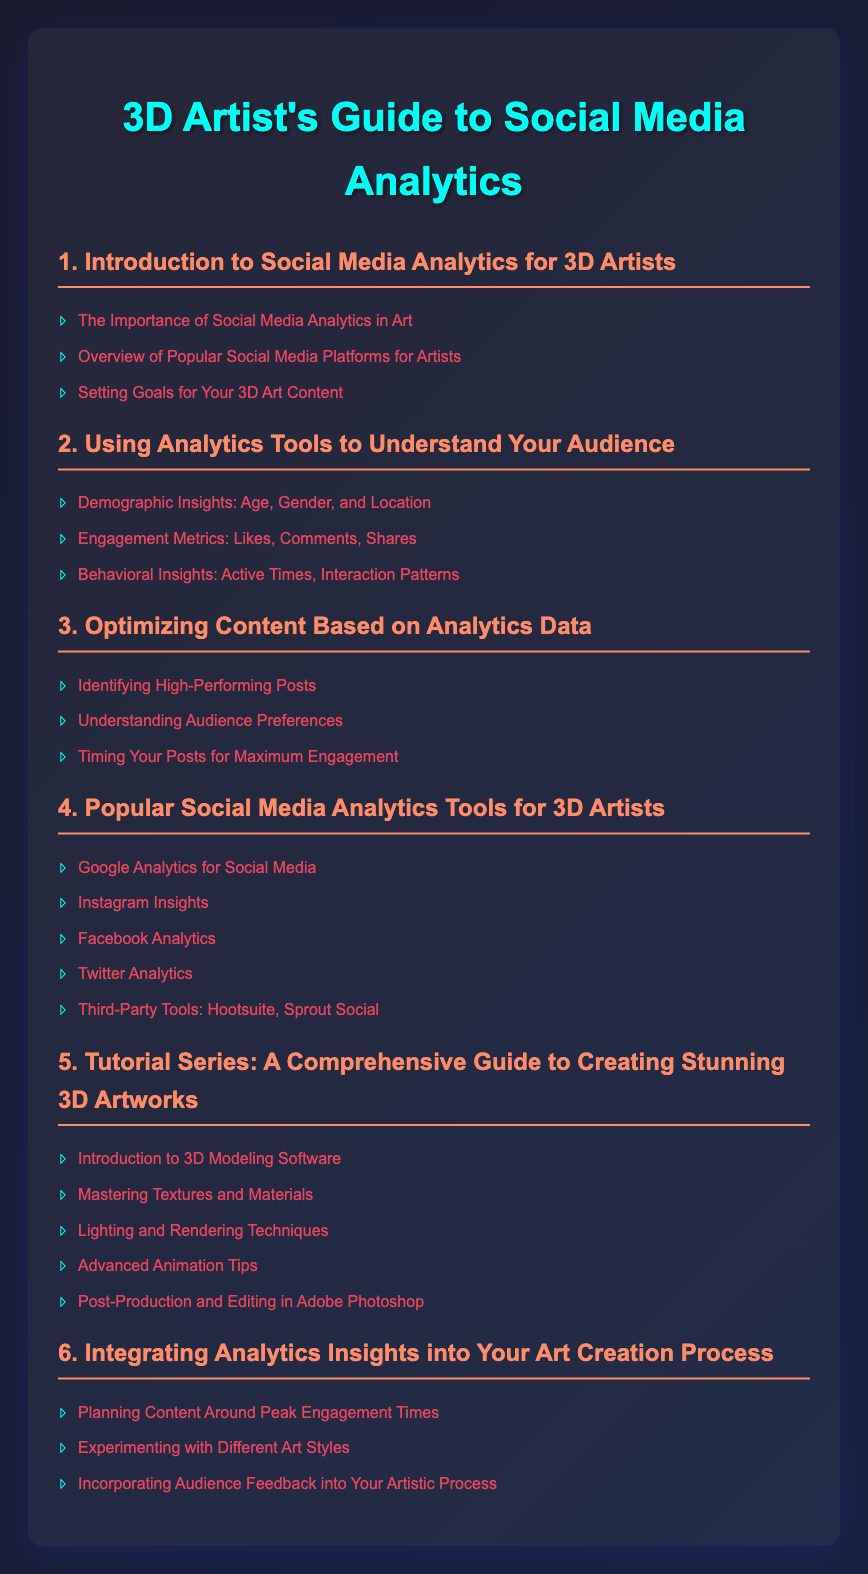What is the title of the document? The title is mentioned in the <title> tag of the document.
Answer: 3D Artist's Guide to Social Media Analytics How many sections are there in the Table of Contents? The document lists sections from 1 to 6, indicating a total of 6 sections.
Answer: 6 What is the first topic under the section "1. Introduction to Social Media Analytics for 3D Artists"? The first topic is listed as the first bullet point under that section.
Answer: The Importance of Social Media Analytics in Art Which social media analytics tool is listed last in the section "4. Popular Social Media Analytics Tools for 3D Artists"? The last item is found as the final bullet point in that section.
Answer: Third-Party Tools: Hootsuite, Sprout Social What section includes "Lighting and Rendering Techniques"? This topic is found under specific section number 5 for tutorials.
Answer: 5 What type of content does section "6. Integrating Analytics Insights into Your Art Creation Process" discuss? This section focuses on incorporating analytics into the artistic process.
Answer: Analytics insights into your art creation process Which software is introduced in the "5. Tutorial Series: A Comprehensive Guide to Creating Stunning 3D Artworks"? This software is highlighted in the first bullet point under section 5.
Answer: 3D Modeling Software 